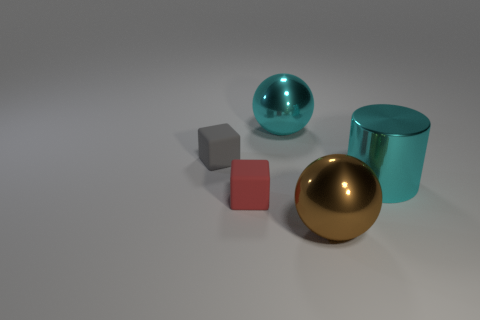There is a cyan thing that is on the right side of the large brown ball; how big is it?
Make the answer very short. Large. How many red matte things are in front of the sphere that is behind the ball to the right of the cyan ball?
Your answer should be compact. 1. Are there any large brown objects behind the tiny red block?
Your answer should be compact. No. How many other objects are the same size as the gray rubber cube?
Keep it short and to the point. 1. There is a large object that is both in front of the small gray block and behind the large brown thing; what is it made of?
Offer a very short reply. Metal. Does the tiny rubber object on the left side of the red block have the same shape as the metal thing that is in front of the small red matte cube?
Provide a succinct answer. No. Is there any other thing that has the same material as the red cube?
Provide a succinct answer. Yes. The big cyan thing that is in front of the cyan thing that is to the left of the big cyan shiny object on the right side of the large brown sphere is what shape?
Keep it short and to the point. Cylinder. What number of other things are the same shape as the tiny red object?
Your answer should be very brief. 1. The matte block that is the same size as the red matte object is what color?
Give a very brief answer. Gray. 